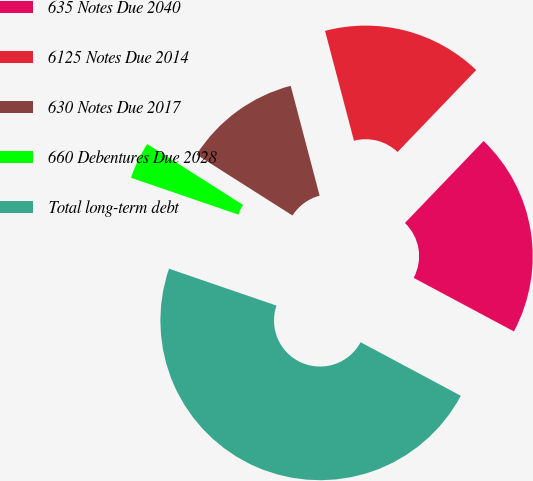Convert chart. <chart><loc_0><loc_0><loc_500><loc_500><pie_chart><fcel>635 Notes Due 2040<fcel>6125 Notes Due 2014<fcel>630 Notes Due 2017<fcel>660 Debentures Due 2028<fcel>Total long-term debt<nl><fcel>20.64%<fcel>16.27%<fcel>11.9%<fcel>3.74%<fcel>47.46%<nl></chart> 